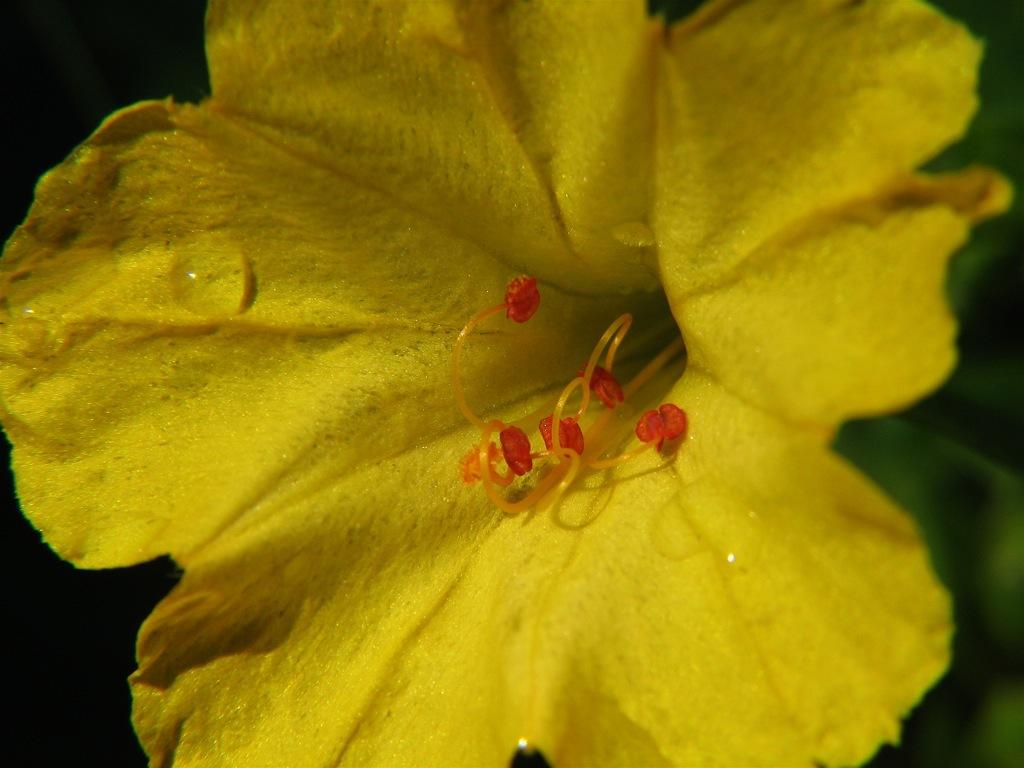What is present in the image? There is a flower in the image. What is the color of the flower? The flower is yellow in color. Can you describe any additional details about the flower? Yes, there are water drops on the flower. How many sheep can be seen grazing near the flower in the image? There are no sheep present in the image; it only features a yellow flower with water drops. 